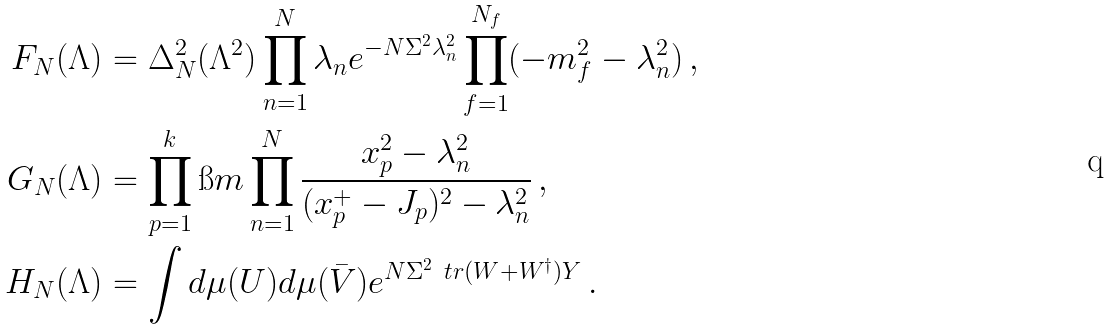<formula> <loc_0><loc_0><loc_500><loc_500>F _ { N } ( \Lambda ) & = \Delta _ { N } ^ { 2 } ( \Lambda ^ { 2 } ) \prod _ { n = 1 } ^ { N } \lambda _ { n } e ^ { - N \Sigma ^ { 2 } \lambda _ { n } ^ { 2 } } \prod _ { f = 1 } ^ { N _ { f } } ( - m _ { f } ^ { 2 } - \lambda _ { n } ^ { 2 } ) \, , \\ G _ { N } ( \Lambda ) & = \prod _ { p = 1 } ^ { k } \i m \prod _ { n = 1 } ^ { N } \frac { x _ { p } ^ { 2 } - \lambda _ { n } ^ { 2 } } { ( x _ { p } ^ { + } - J _ { p } ) ^ { 2 } - \lambda _ { n } ^ { 2 } } \, , \\ H _ { N } ( \Lambda ) & = \int d \mu ( U ) d \mu ( \bar { V } ) e ^ { N \Sigma ^ { 2 } \ t r ( W + W ^ { \dagger } ) Y } \, .</formula> 